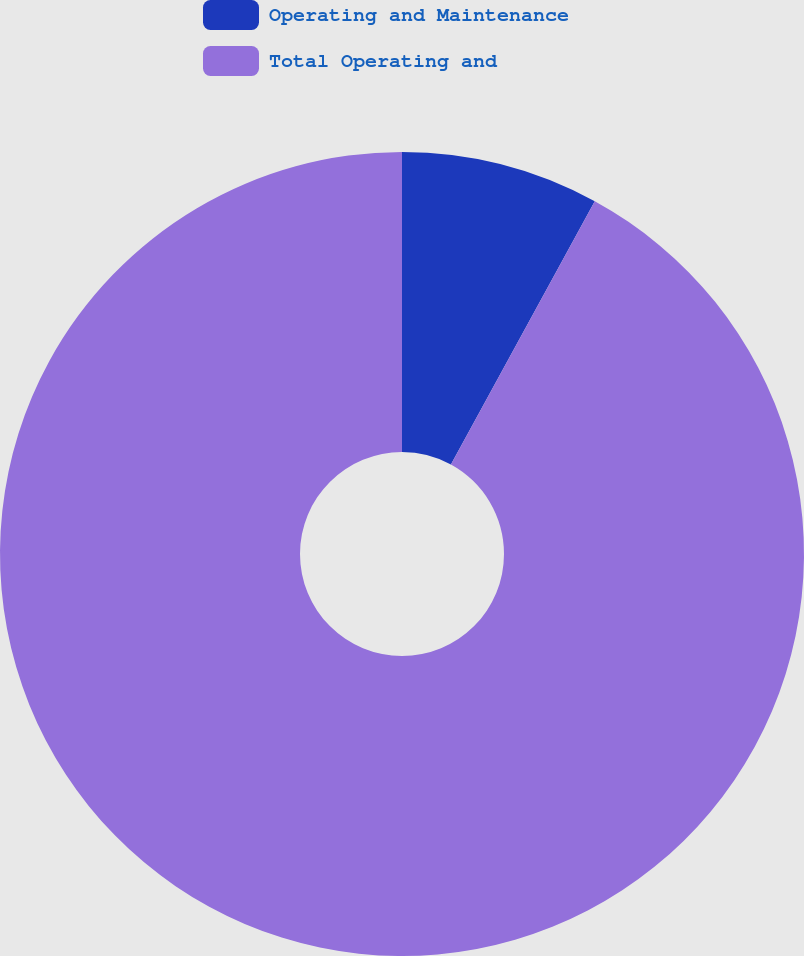Convert chart to OTSL. <chart><loc_0><loc_0><loc_500><loc_500><pie_chart><fcel>Operating and Maintenance<fcel>Total Operating and<nl><fcel>7.96%<fcel>92.04%<nl></chart> 